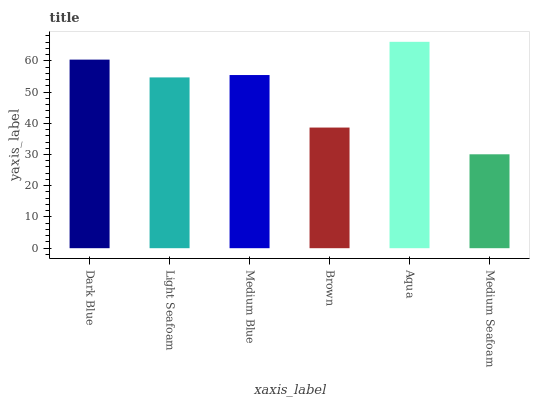Is Medium Seafoam the minimum?
Answer yes or no. Yes. Is Aqua the maximum?
Answer yes or no. Yes. Is Light Seafoam the minimum?
Answer yes or no. No. Is Light Seafoam the maximum?
Answer yes or no. No. Is Dark Blue greater than Light Seafoam?
Answer yes or no. Yes. Is Light Seafoam less than Dark Blue?
Answer yes or no. Yes. Is Light Seafoam greater than Dark Blue?
Answer yes or no. No. Is Dark Blue less than Light Seafoam?
Answer yes or no. No. Is Medium Blue the high median?
Answer yes or no. Yes. Is Light Seafoam the low median?
Answer yes or no. Yes. Is Light Seafoam the high median?
Answer yes or no. No. Is Medium Seafoam the low median?
Answer yes or no. No. 